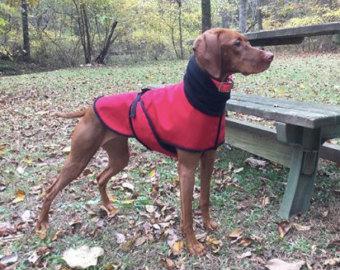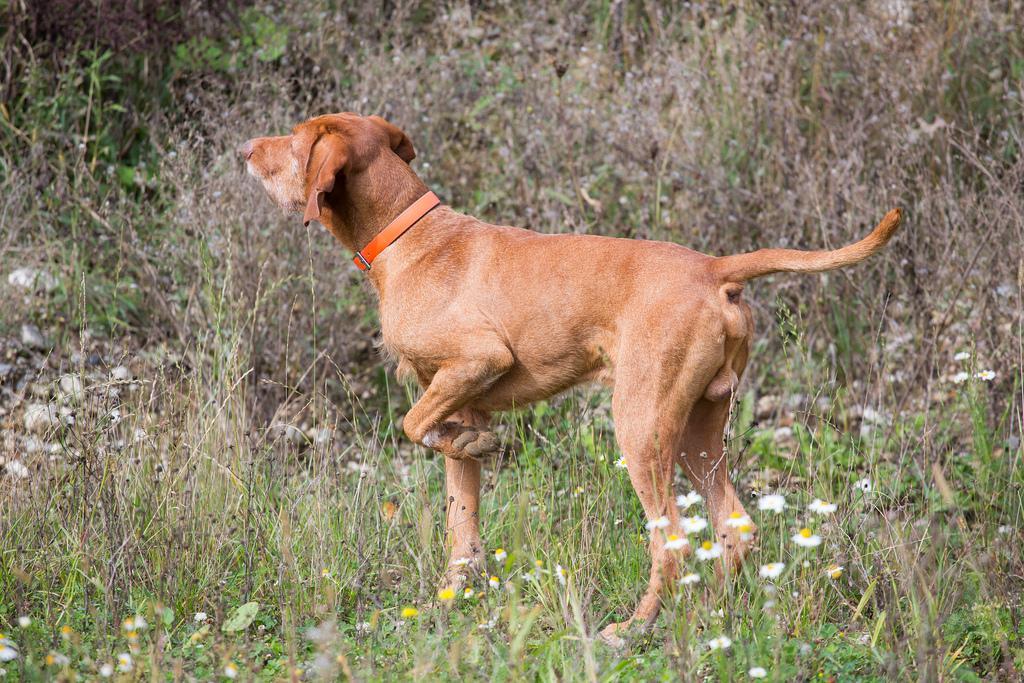The first image is the image on the left, the second image is the image on the right. For the images shown, is this caption "One image shows a red-orange dog standing in profile with its head upright, tail outstretched, and a front paw raised and bent inward." true? Answer yes or no. Yes. The first image is the image on the left, the second image is the image on the right. For the images shown, is this caption "In one image a dog is standing with one front leg raised up and its tail extended behind it." true? Answer yes or no. Yes. 